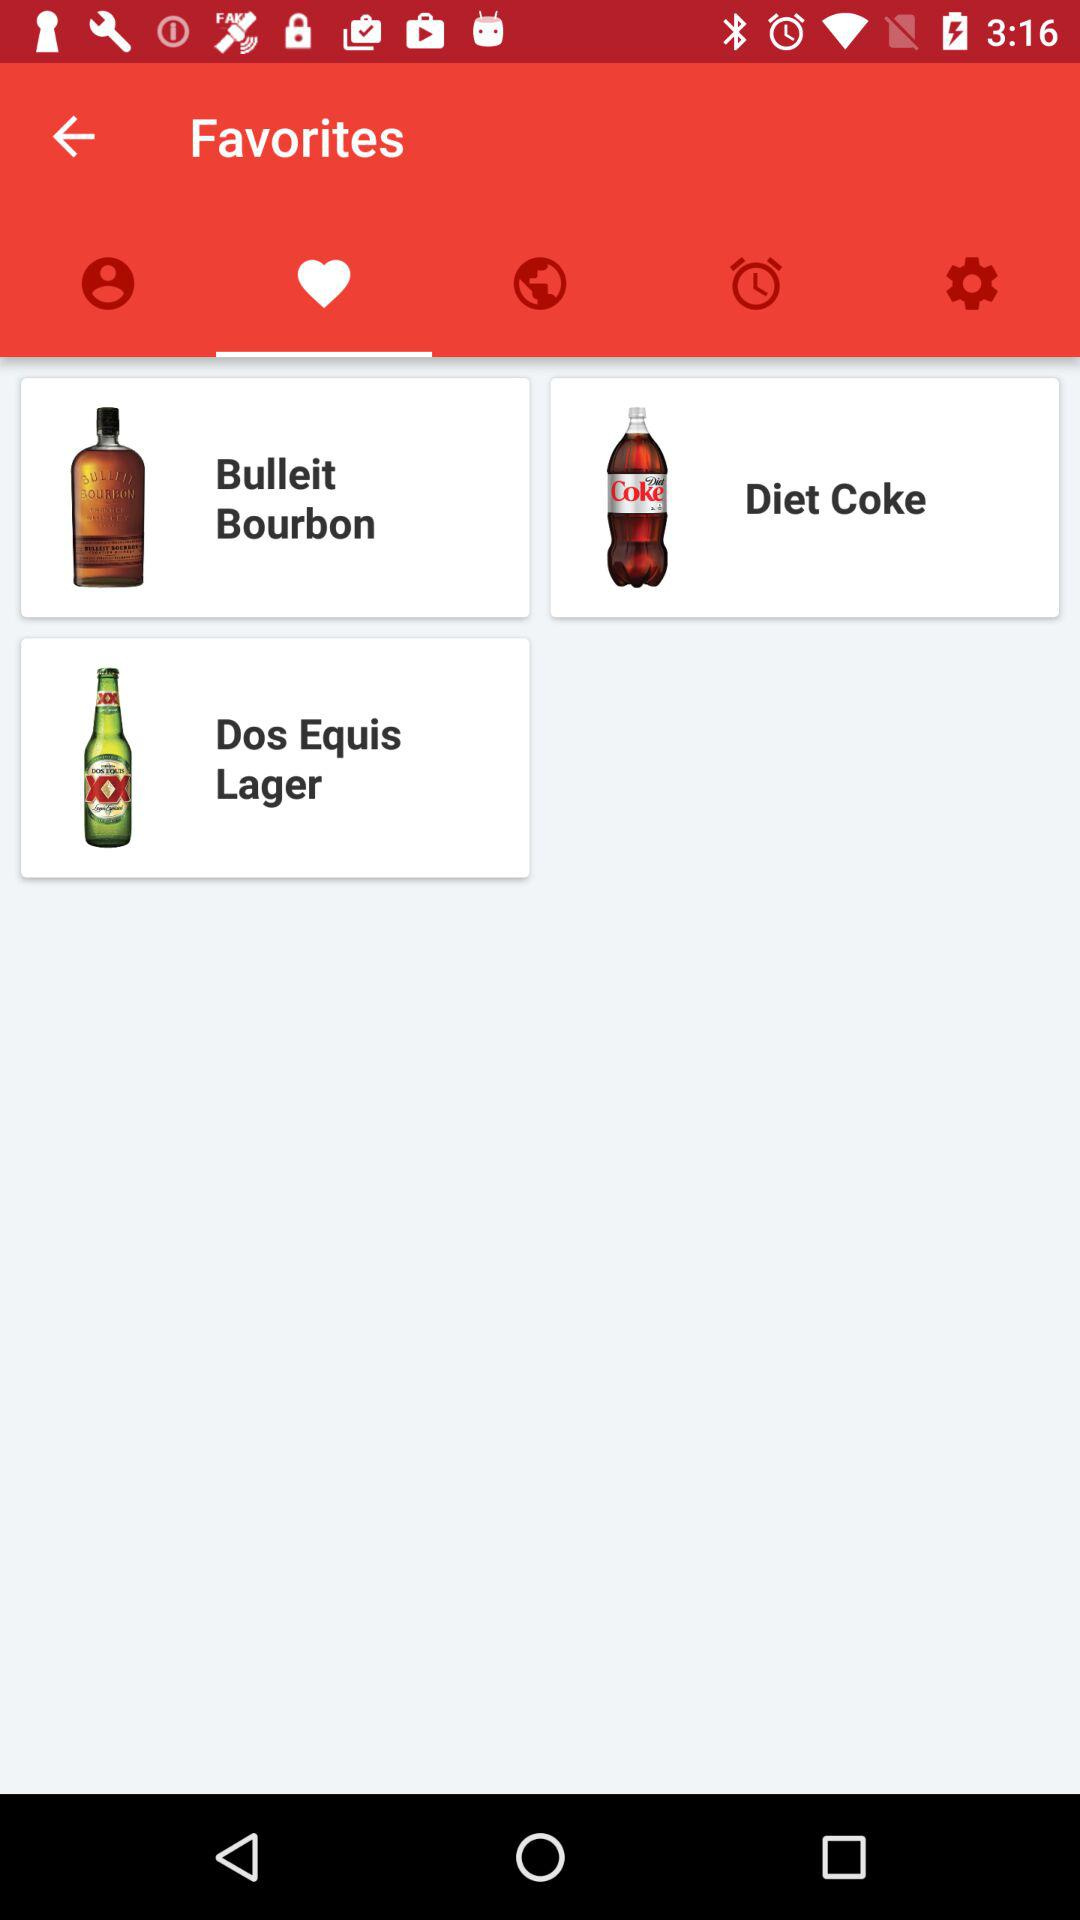What items are there in the "Favorites" tab? The items in the "Favorites" tab are "Bulleit Bourbon", "Diet Coke" and "Dos Equis Lager". 